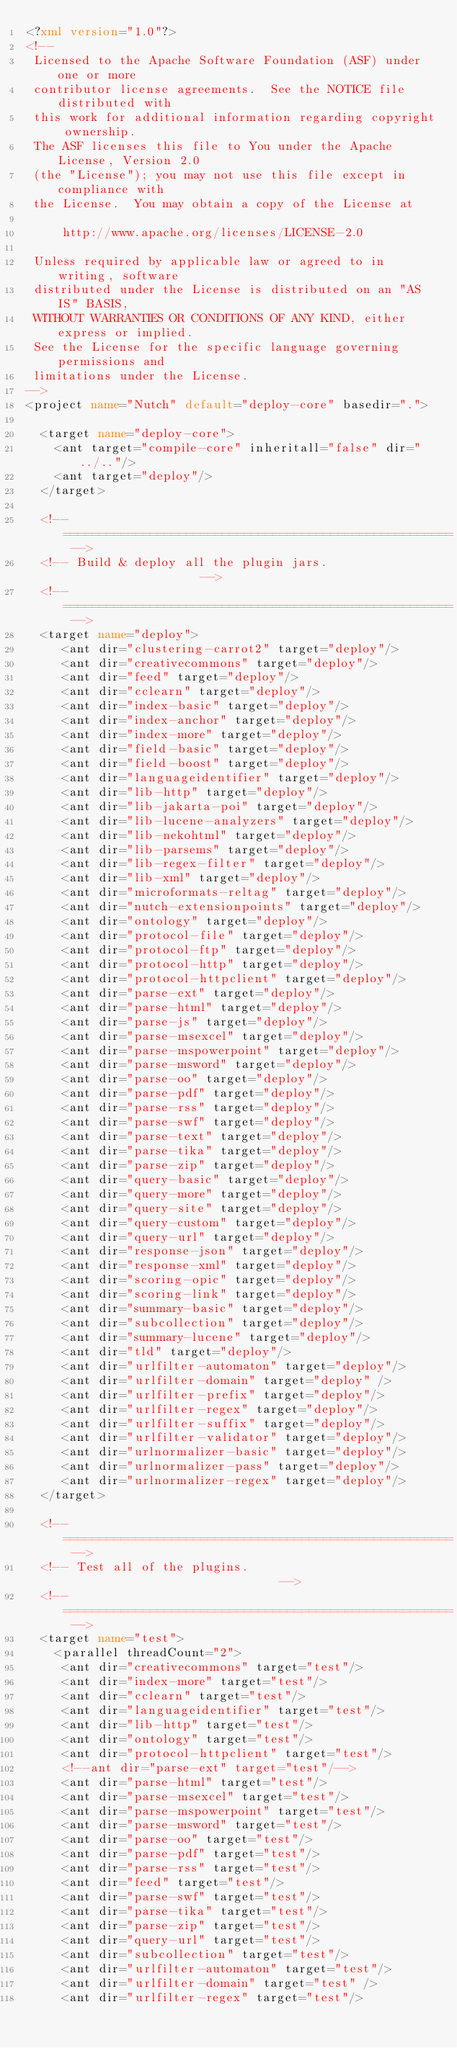<code> <loc_0><loc_0><loc_500><loc_500><_XML_><?xml version="1.0"?>
<!--
 Licensed to the Apache Software Foundation (ASF) under one or more
 contributor license agreements.  See the NOTICE file distributed with
 this work for additional information regarding copyright ownership.
 The ASF licenses this file to You under the Apache License, Version 2.0
 (the "License"); you may not use this file except in compliance with
 the License.  You may obtain a copy of the License at

     http://www.apache.org/licenses/LICENSE-2.0

 Unless required by applicable law or agreed to in writing, software
 distributed under the License is distributed on an "AS IS" BASIS,
 WITHOUT WARRANTIES OR CONDITIONS OF ANY KIND, either express or implied.
 See the License for the specific language governing permissions and
 limitations under the License.
-->
<project name="Nutch" default="deploy-core" basedir=".">

  <target name="deploy-core">
    <ant target="compile-core" inheritall="false" dir="../.."/>
    <ant target="deploy"/>
  </target>

  <!-- ====================================================== -->
  <!-- Build & deploy all the plugin jars.                    -->
  <!-- ====================================================== -->
  <target name="deploy">
     <ant dir="clustering-carrot2" target="deploy"/>
     <ant dir="creativecommons" target="deploy"/>
     <ant dir="feed" target="deploy"/>
     <ant dir="cclearn" target="deploy"/>
     <ant dir="index-basic" target="deploy"/>
     <ant dir="index-anchor" target="deploy"/>
     <ant dir="index-more" target="deploy"/>
     <ant dir="field-basic" target="deploy"/>
     <ant dir="field-boost" target="deploy"/>
     <ant dir="languageidentifier" target="deploy"/>
     <ant dir="lib-http" target="deploy"/>
     <ant dir="lib-jakarta-poi" target="deploy"/>
     <ant dir="lib-lucene-analyzers" target="deploy"/>
     <ant dir="lib-nekohtml" target="deploy"/>
     <ant dir="lib-parsems" target="deploy"/>
     <ant dir="lib-regex-filter" target="deploy"/>
     <ant dir="lib-xml" target="deploy"/>
     <ant dir="microformats-reltag" target="deploy"/>
     <ant dir="nutch-extensionpoints" target="deploy"/>
     <ant dir="ontology" target="deploy"/>
     <ant dir="protocol-file" target="deploy"/>
     <ant dir="protocol-ftp" target="deploy"/>
     <ant dir="protocol-http" target="deploy"/>
     <ant dir="protocol-httpclient" target="deploy"/>
     <ant dir="parse-ext" target="deploy"/>
     <ant dir="parse-html" target="deploy"/>
     <ant dir="parse-js" target="deploy"/>
     <ant dir="parse-msexcel" target="deploy"/>
     <ant dir="parse-mspowerpoint" target="deploy"/>
     <ant dir="parse-msword" target="deploy"/>
     <ant dir="parse-oo" target="deploy"/>
     <ant dir="parse-pdf" target="deploy"/>
     <ant dir="parse-rss" target="deploy"/>
     <ant dir="parse-swf" target="deploy"/>
     <ant dir="parse-text" target="deploy"/>
     <ant dir="parse-tika" target="deploy"/>
     <ant dir="parse-zip" target="deploy"/>
     <ant dir="query-basic" target="deploy"/>
     <ant dir="query-more" target="deploy"/>
     <ant dir="query-site" target="deploy"/>
     <ant dir="query-custom" target="deploy"/>
     <ant dir="query-url" target="deploy"/>
     <ant dir="response-json" target="deploy"/>
     <ant dir="response-xml" target="deploy"/>
     <ant dir="scoring-opic" target="deploy"/>
     <ant dir="scoring-link" target="deploy"/>
     <ant dir="summary-basic" target="deploy"/>
     <ant dir="subcollection" target="deploy"/>
     <ant dir="summary-lucene" target="deploy"/>
     <ant dir="tld" target="deploy"/>
     <ant dir="urlfilter-automaton" target="deploy"/>
     <ant dir="urlfilter-domain" target="deploy" />
     <ant dir="urlfilter-prefix" target="deploy"/>
     <ant dir="urlfilter-regex" target="deploy"/>
     <ant dir="urlfilter-suffix" target="deploy"/>
     <ant dir="urlfilter-validator" target="deploy"/>
     <ant dir="urlnormalizer-basic" target="deploy"/>
     <ant dir="urlnormalizer-pass" target="deploy"/>
     <ant dir="urlnormalizer-regex" target="deploy"/>
  </target>

  <!-- ====================================================== -->
  <!-- Test all of the plugins.                               -->
  <!-- ====================================================== -->
  <target name="test">
    <parallel threadCount="2">
     <ant dir="creativecommons" target="test"/>
     <ant dir="index-more" target="test"/>
     <ant dir="cclearn" target="test"/>
     <ant dir="languageidentifier" target="test"/>
     <ant dir="lib-http" target="test"/>
     <ant dir="ontology" target="test"/>
     <ant dir="protocol-httpclient" target="test"/>
     <!--ant dir="parse-ext" target="test"/-->
     <ant dir="parse-html" target="test"/>
     <ant dir="parse-msexcel" target="test"/>
     <ant dir="parse-mspowerpoint" target="test"/>
     <ant dir="parse-msword" target="test"/>
     <ant dir="parse-oo" target="test"/>
     <ant dir="parse-pdf" target="test"/>
     <ant dir="parse-rss" target="test"/>
     <ant dir="feed" target="test"/>
     <ant dir="parse-swf" target="test"/>
     <ant dir="parse-tika" target="test"/>
     <ant dir="parse-zip" target="test"/>
     <ant dir="query-url" target="test"/>
     <ant dir="subcollection" target="test"/>
     <ant dir="urlfilter-automaton" target="test"/>
     <ant dir="urlfilter-domain" target="test" />
     <ant dir="urlfilter-regex" target="test"/></code> 